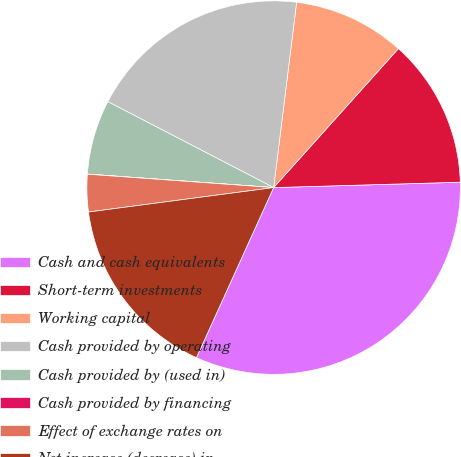Convert chart. <chart><loc_0><loc_0><loc_500><loc_500><pie_chart><fcel>Cash and cash equivalents<fcel>Short-term investments<fcel>Working capital<fcel>Cash provided by operating<fcel>Cash provided by (used in)<fcel>Cash provided by financing<fcel>Effect of exchange rates on<fcel>Net increase (decrease) in<nl><fcel>32.24%<fcel>12.9%<fcel>9.68%<fcel>19.35%<fcel>6.46%<fcel>0.01%<fcel>3.23%<fcel>16.13%<nl></chart> 